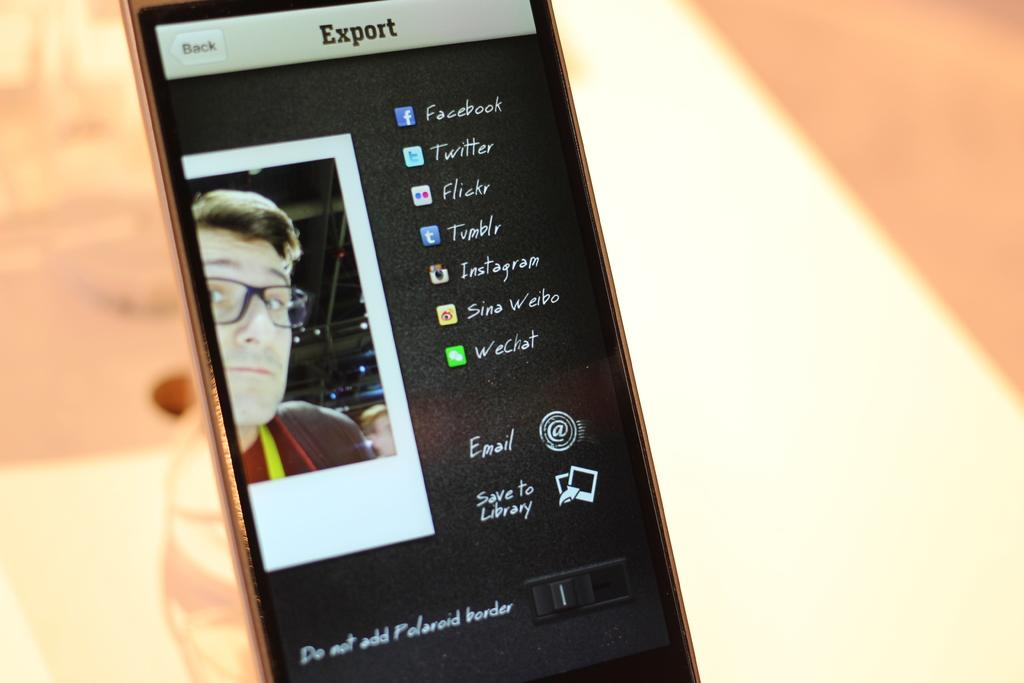<image>
Present a compact description of the photo's key features. A cell phone with a photo opened to the export feature for social media. 